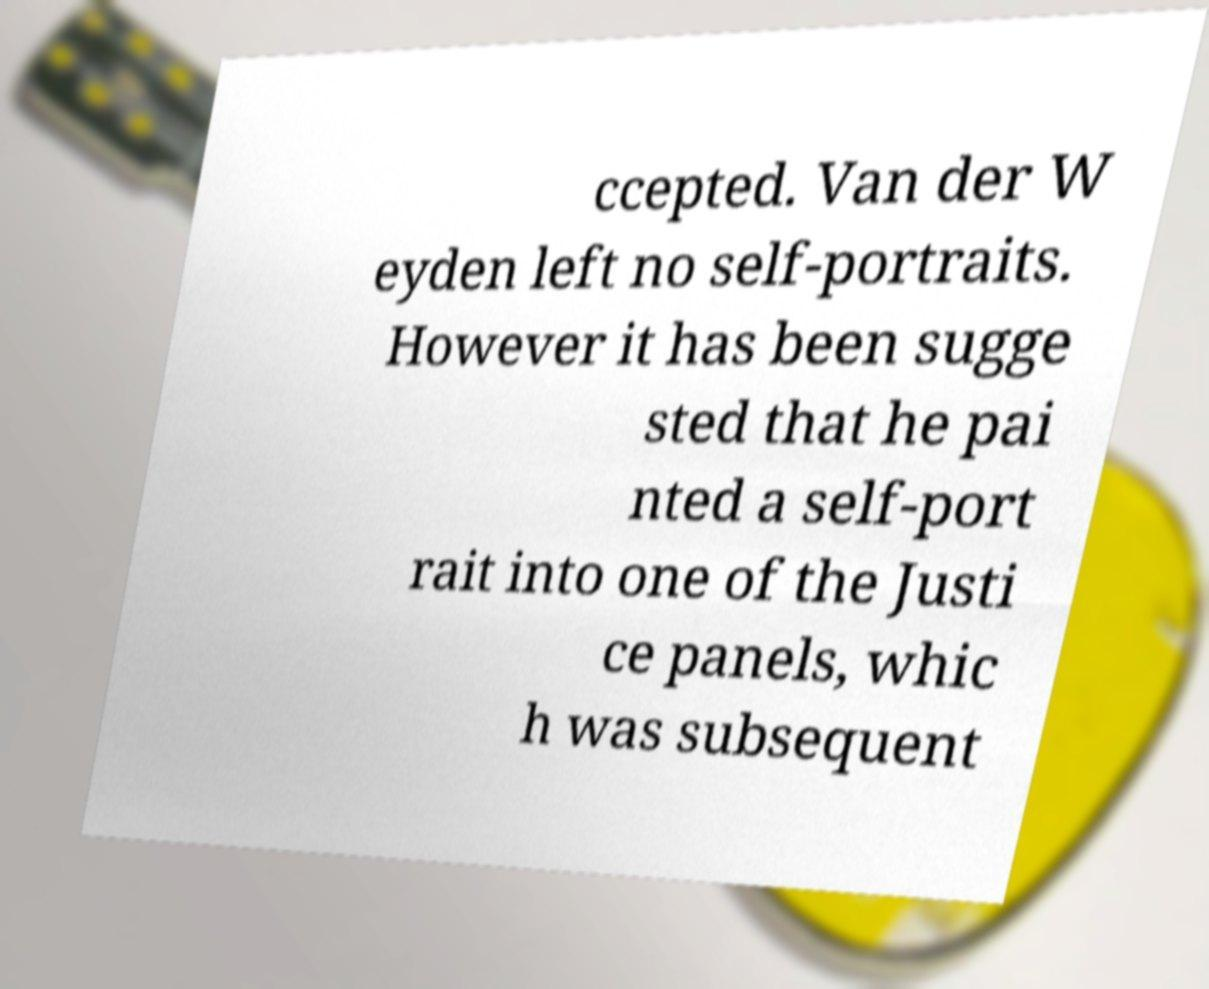Could you assist in decoding the text presented in this image and type it out clearly? ccepted. Van der W eyden left no self-portraits. However it has been sugge sted that he pai nted a self-port rait into one of the Justi ce panels, whic h was subsequent 